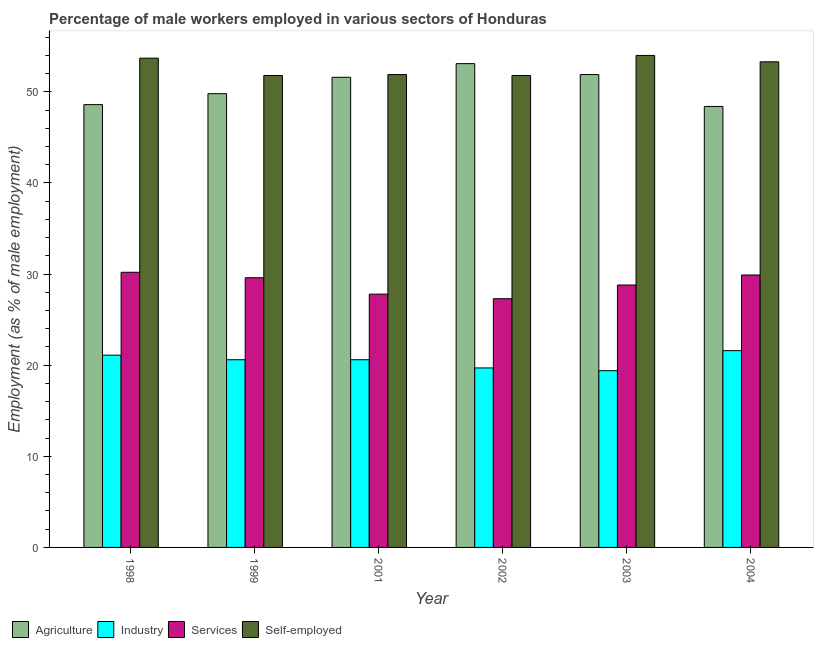How many different coloured bars are there?
Ensure brevity in your answer.  4. How many groups of bars are there?
Ensure brevity in your answer.  6. Are the number of bars per tick equal to the number of legend labels?
Ensure brevity in your answer.  Yes. Are the number of bars on each tick of the X-axis equal?
Provide a short and direct response. Yes. How many bars are there on the 1st tick from the right?
Offer a very short reply. 4. What is the label of the 3rd group of bars from the left?
Provide a short and direct response. 2001. What is the percentage of male workers in services in 1999?
Keep it short and to the point. 29.6. Across all years, what is the maximum percentage of self employed male workers?
Offer a terse response. 54. Across all years, what is the minimum percentage of self employed male workers?
Ensure brevity in your answer.  51.8. In which year was the percentage of male workers in industry minimum?
Ensure brevity in your answer.  2003. What is the total percentage of male workers in services in the graph?
Provide a short and direct response. 173.6. What is the difference between the percentage of male workers in industry in 2004 and the percentage of self employed male workers in 1998?
Offer a terse response. 0.5. What is the average percentage of male workers in industry per year?
Keep it short and to the point. 20.5. In how many years, is the percentage of self employed male workers greater than 54 %?
Give a very brief answer. 0. What is the ratio of the percentage of male workers in services in 2001 to that in 2004?
Your response must be concise. 0.93. Is the difference between the percentage of male workers in agriculture in 1998 and 2004 greater than the difference between the percentage of male workers in services in 1998 and 2004?
Ensure brevity in your answer.  No. What is the difference between the highest and the second highest percentage of male workers in services?
Give a very brief answer. 0.3. What is the difference between the highest and the lowest percentage of male workers in agriculture?
Your response must be concise. 4.7. In how many years, is the percentage of male workers in agriculture greater than the average percentage of male workers in agriculture taken over all years?
Ensure brevity in your answer.  3. Is it the case that in every year, the sum of the percentage of male workers in services and percentage of male workers in industry is greater than the sum of percentage of male workers in agriculture and percentage of self employed male workers?
Your answer should be very brief. No. What does the 4th bar from the left in 2003 represents?
Provide a succinct answer. Self-employed. What does the 1st bar from the right in 1998 represents?
Give a very brief answer. Self-employed. Is it the case that in every year, the sum of the percentage of male workers in agriculture and percentage of male workers in industry is greater than the percentage of male workers in services?
Ensure brevity in your answer.  Yes. How many bars are there?
Your response must be concise. 24. Does the graph contain grids?
Provide a short and direct response. No. Where does the legend appear in the graph?
Your response must be concise. Bottom left. How are the legend labels stacked?
Your answer should be very brief. Horizontal. What is the title of the graph?
Ensure brevity in your answer.  Percentage of male workers employed in various sectors of Honduras. What is the label or title of the X-axis?
Offer a terse response. Year. What is the label or title of the Y-axis?
Make the answer very short. Employment (as % of male employment). What is the Employment (as % of male employment) of Agriculture in 1998?
Make the answer very short. 48.6. What is the Employment (as % of male employment) in Industry in 1998?
Give a very brief answer. 21.1. What is the Employment (as % of male employment) in Services in 1998?
Your answer should be compact. 30.2. What is the Employment (as % of male employment) of Self-employed in 1998?
Your answer should be very brief. 53.7. What is the Employment (as % of male employment) of Agriculture in 1999?
Give a very brief answer. 49.8. What is the Employment (as % of male employment) in Industry in 1999?
Make the answer very short. 20.6. What is the Employment (as % of male employment) of Services in 1999?
Keep it short and to the point. 29.6. What is the Employment (as % of male employment) of Self-employed in 1999?
Provide a succinct answer. 51.8. What is the Employment (as % of male employment) of Agriculture in 2001?
Provide a succinct answer. 51.6. What is the Employment (as % of male employment) in Industry in 2001?
Offer a terse response. 20.6. What is the Employment (as % of male employment) of Services in 2001?
Your response must be concise. 27.8. What is the Employment (as % of male employment) of Self-employed in 2001?
Your response must be concise. 51.9. What is the Employment (as % of male employment) in Agriculture in 2002?
Give a very brief answer. 53.1. What is the Employment (as % of male employment) in Industry in 2002?
Offer a very short reply. 19.7. What is the Employment (as % of male employment) in Services in 2002?
Offer a very short reply. 27.3. What is the Employment (as % of male employment) of Self-employed in 2002?
Provide a short and direct response. 51.8. What is the Employment (as % of male employment) of Agriculture in 2003?
Offer a very short reply. 51.9. What is the Employment (as % of male employment) in Industry in 2003?
Ensure brevity in your answer.  19.4. What is the Employment (as % of male employment) in Services in 2003?
Your response must be concise. 28.8. What is the Employment (as % of male employment) of Agriculture in 2004?
Offer a very short reply. 48.4. What is the Employment (as % of male employment) of Industry in 2004?
Offer a very short reply. 21.6. What is the Employment (as % of male employment) of Services in 2004?
Provide a short and direct response. 29.9. What is the Employment (as % of male employment) of Self-employed in 2004?
Provide a short and direct response. 53.3. Across all years, what is the maximum Employment (as % of male employment) of Agriculture?
Keep it short and to the point. 53.1. Across all years, what is the maximum Employment (as % of male employment) in Industry?
Give a very brief answer. 21.6. Across all years, what is the maximum Employment (as % of male employment) in Services?
Offer a terse response. 30.2. Across all years, what is the minimum Employment (as % of male employment) in Agriculture?
Your answer should be compact. 48.4. Across all years, what is the minimum Employment (as % of male employment) in Industry?
Your answer should be very brief. 19.4. Across all years, what is the minimum Employment (as % of male employment) of Services?
Make the answer very short. 27.3. Across all years, what is the minimum Employment (as % of male employment) of Self-employed?
Your response must be concise. 51.8. What is the total Employment (as % of male employment) in Agriculture in the graph?
Keep it short and to the point. 303.4. What is the total Employment (as % of male employment) in Industry in the graph?
Ensure brevity in your answer.  123. What is the total Employment (as % of male employment) of Services in the graph?
Offer a terse response. 173.6. What is the total Employment (as % of male employment) in Self-employed in the graph?
Your answer should be compact. 316.5. What is the difference between the Employment (as % of male employment) of Agriculture in 1998 and that in 2001?
Keep it short and to the point. -3. What is the difference between the Employment (as % of male employment) in Industry in 1998 and that in 2002?
Ensure brevity in your answer.  1.4. What is the difference between the Employment (as % of male employment) of Industry in 1998 and that in 2003?
Your response must be concise. 1.7. What is the difference between the Employment (as % of male employment) of Services in 1998 and that in 2003?
Provide a short and direct response. 1.4. What is the difference between the Employment (as % of male employment) in Agriculture in 1998 and that in 2004?
Your answer should be very brief. 0.2. What is the difference between the Employment (as % of male employment) of Services in 1998 and that in 2004?
Your answer should be compact. 0.3. What is the difference between the Employment (as % of male employment) of Services in 1999 and that in 2002?
Ensure brevity in your answer.  2.3. What is the difference between the Employment (as % of male employment) in Self-employed in 1999 and that in 2002?
Ensure brevity in your answer.  0. What is the difference between the Employment (as % of male employment) in Agriculture in 1999 and that in 2003?
Give a very brief answer. -2.1. What is the difference between the Employment (as % of male employment) of Industry in 1999 and that in 2003?
Provide a short and direct response. 1.2. What is the difference between the Employment (as % of male employment) of Self-employed in 1999 and that in 2003?
Provide a succinct answer. -2.2. What is the difference between the Employment (as % of male employment) in Agriculture in 1999 and that in 2004?
Make the answer very short. 1.4. What is the difference between the Employment (as % of male employment) of Services in 1999 and that in 2004?
Provide a succinct answer. -0.3. What is the difference between the Employment (as % of male employment) of Self-employed in 1999 and that in 2004?
Your answer should be very brief. -1.5. What is the difference between the Employment (as % of male employment) of Industry in 2001 and that in 2002?
Provide a short and direct response. 0.9. What is the difference between the Employment (as % of male employment) in Self-employed in 2001 and that in 2002?
Provide a short and direct response. 0.1. What is the difference between the Employment (as % of male employment) of Agriculture in 2001 and that in 2003?
Your answer should be very brief. -0.3. What is the difference between the Employment (as % of male employment) of Self-employed in 2001 and that in 2003?
Keep it short and to the point. -2.1. What is the difference between the Employment (as % of male employment) in Industry in 2001 and that in 2004?
Provide a short and direct response. -1. What is the difference between the Employment (as % of male employment) of Services in 2001 and that in 2004?
Your answer should be very brief. -2.1. What is the difference between the Employment (as % of male employment) in Agriculture in 2002 and that in 2003?
Make the answer very short. 1.2. What is the difference between the Employment (as % of male employment) of Industry in 2002 and that in 2003?
Ensure brevity in your answer.  0.3. What is the difference between the Employment (as % of male employment) in Self-employed in 2002 and that in 2003?
Your answer should be very brief. -2.2. What is the difference between the Employment (as % of male employment) of Industry in 2002 and that in 2004?
Make the answer very short. -1.9. What is the difference between the Employment (as % of male employment) in Services in 2002 and that in 2004?
Your answer should be compact. -2.6. What is the difference between the Employment (as % of male employment) in Self-employed in 2002 and that in 2004?
Provide a succinct answer. -1.5. What is the difference between the Employment (as % of male employment) in Agriculture in 2003 and that in 2004?
Offer a very short reply. 3.5. What is the difference between the Employment (as % of male employment) in Industry in 2003 and that in 2004?
Provide a succinct answer. -2.2. What is the difference between the Employment (as % of male employment) of Agriculture in 1998 and the Employment (as % of male employment) of Self-employed in 1999?
Give a very brief answer. -3.2. What is the difference between the Employment (as % of male employment) of Industry in 1998 and the Employment (as % of male employment) of Self-employed in 1999?
Provide a succinct answer. -30.7. What is the difference between the Employment (as % of male employment) in Services in 1998 and the Employment (as % of male employment) in Self-employed in 1999?
Keep it short and to the point. -21.6. What is the difference between the Employment (as % of male employment) in Agriculture in 1998 and the Employment (as % of male employment) in Services in 2001?
Provide a short and direct response. 20.8. What is the difference between the Employment (as % of male employment) in Industry in 1998 and the Employment (as % of male employment) in Self-employed in 2001?
Give a very brief answer. -30.8. What is the difference between the Employment (as % of male employment) in Services in 1998 and the Employment (as % of male employment) in Self-employed in 2001?
Provide a short and direct response. -21.7. What is the difference between the Employment (as % of male employment) in Agriculture in 1998 and the Employment (as % of male employment) in Industry in 2002?
Keep it short and to the point. 28.9. What is the difference between the Employment (as % of male employment) in Agriculture in 1998 and the Employment (as % of male employment) in Services in 2002?
Give a very brief answer. 21.3. What is the difference between the Employment (as % of male employment) of Agriculture in 1998 and the Employment (as % of male employment) of Self-employed in 2002?
Provide a short and direct response. -3.2. What is the difference between the Employment (as % of male employment) of Industry in 1998 and the Employment (as % of male employment) of Services in 2002?
Keep it short and to the point. -6.2. What is the difference between the Employment (as % of male employment) in Industry in 1998 and the Employment (as % of male employment) in Self-employed in 2002?
Your answer should be compact. -30.7. What is the difference between the Employment (as % of male employment) of Services in 1998 and the Employment (as % of male employment) of Self-employed in 2002?
Offer a very short reply. -21.6. What is the difference between the Employment (as % of male employment) of Agriculture in 1998 and the Employment (as % of male employment) of Industry in 2003?
Offer a terse response. 29.2. What is the difference between the Employment (as % of male employment) in Agriculture in 1998 and the Employment (as % of male employment) in Services in 2003?
Keep it short and to the point. 19.8. What is the difference between the Employment (as % of male employment) of Agriculture in 1998 and the Employment (as % of male employment) of Self-employed in 2003?
Provide a short and direct response. -5.4. What is the difference between the Employment (as % of male employment) of Industry in 1998 and the Employment (as % of male employment) of Services in 2003?
Provide a succinct answer. -7.7. What is the difference between the Employment (as % of male employment) of Industry in 1998 and the Employment (as % of male employment) of Self-employed in 2003?
Your answer should be compact. -32.9. What is the difference between the Employment (as % of male employment) of Services in 1998 and the Employment (as % of male employment) of Self-employed in 2003?
Your response must be concise. -23.8. What is the difference between the Employment (as % of male employment) in Industry in 1998 and the Employment (as % of male employment) in Services in 2004?
Make the answer very short. -8.8. What is the difference between the Employment (as % of male employment) of Industry in 1998 and the Employment (as % of male employment) of Self-employed in 2004?
Keep it short and to the point. -32.2. What is the difference between the Employment (as % of male employment) in Services in 1998 and the Employment (as % of male employment) in Self-employed in 2004?
Your response must be concise. -23.1. What is the difference between the Employment (as % of male employment) of Agriculture in 1999 and the Employment (as % of male employment) of Industry in 2001?
Your response must be concise. 29.2. What is the difference between the Employment (as % of male employment) of Agriculture in 1999 and the Employment (as % of male employment) of Services in 2001?
Your answer should be compact. 22. What is the difference between the Employment (as % of male employment) in Industry in 1999 and the Employment (as % of male employment) in Services in 2001?
Offer a very short reply. -7.2. What is the difference between the Employment (as % of male employment) of Industry in 1999 and the Employment (as % of male employment) of Self-employed in 2001?
Provide a short and direct response. -31.3. What is the difference between the Employment (as % of male employment) in Services in 1999 and the Employment (as % of male employment) in Self-employed in 2001?
Give a very brief answer. -22.3. What is the difference between the Employment (as % of male employment) of Agriculture in 1999 and the Employment (as % of male employment) of Industry in 2002?
Ensure brevity in your answer.  30.1. What is the difference between the Employment (as % of male employment) in Agriculture in 1999 and the Employment (as % of male employment) in Services in 2002?
Ensure brevity in your answer.  22.5. What is the difference between the Employment (as % of male employment) of Agriculture in 1999 and the Employment (as % of male employment) of Self-employed in 2002?
Offer a terse response. -2. What is the difference between the Employment (as % of male employment) in Industry in 1999 and the Employment (as % of male employment) in Services in 2002?
Offer a terse response. -6.7. What is the difference between the Employment (as % of male employment) in Industry in 1999 and the Employment (as % of male employment) in Self-employed in 2002?
Your answer should be very brief. -31.2. What is the difference between the Employment (as % of male employment) of Services in 1999 and the Employment (as % of male employment) of Self-employed in 2002?
Give a very brief answer. -22.2. What is the difference between the Employment (as % of male employment) in Agriculture in 1999 and the Employment (as % of male employment) in Industry in 2003?
Your answer should be compact. 30.4. What is the difference between the Employment (as % of male employment) in Agriculture in 1999 and the Employment (as % of male employment) in Services in 2003?
Your answer should be compact. 21. What is the difference between the Employment (as % of male employment) in Industry in 1999 and the Employment (as % of male employment) in Self-employed in 2003?
Ensure brevity in your answer.  -33.4. What is the difference between the Employment (as % of male employment) in Services in 1999 and the Employment (as % of male employment) in Self-employed in 2003?
Ensure brevity in your answer.  -24.4. What is the difference between the Employment (as % of male employment) of Agriculture in 1999 and the Employment (as % of male employment) of Industry in 2004?
Provide a succinct answer. 28.2. What is the difference between the Employment (as % of male employment) in Agriculture in 1999 and the Employment (as % of male employment) in Self-employed in 2004?
Make the answer very short. -3.5. What is the difference between the Employment (as % of male employment) of Industry in 1999 and the Employment (as % of male employment) of Self-employed in 2004?
Make the answer very short. -32.7. What is the difference between the Employment (as % of male employment) of Services in 1999 and the Employment (as % of male employment) of Self-employed in 2004?
Your answer should be compact. -23.7. What is the difference between the Employment (as % of male employment) of Agriculture in 2001 and the Employment (as % of male employment) of Industry in 2002?
Offer a very short reply. 31.9. What is the difference between the Employment (as % of male employment) of Agriculture in 2001 and the Employment (as % of male employment) of Services in 2002?
Provide a short and direct response. 24.3. What is the difference between the Employment (as % of male employment) of Agriculture in 2001 and the Employment (as % of male employment) of Self-employed in 2002?
Your answer should be compact. -0.2. What is the difference between the Employment (as % of male employment) in Industry in 2001 and the Employment (as % of male employment) in Services in 2002?
Your answer should be very brief. -6.7. What is the difference between the Employment (as % of male employment) in Industry in 2001 and the Employment (as % of male employment) in Self-employed in 2002?
Keep it short and to the point. -31.2. What is the difference between the Employment (as % of male employment) of Agriculture in 2001 and the Employment (as % of male employment) of Industry in 2003?
Give a very brief answer. 32.2. What is the difference between the Employment (as % of male employment) in Agriculture in 2001 and the Employment (as % of male employment) in Services in 2003?
Your answer should be compact. 22.8. What is the difference between the Employment (as % of male employment) in Industry in 2001 and the Employment (as % of male employment) in Self-employed in 2003?
Provide a short and direct response. -33.4. What is the difference between the Employment (as % of male employment) of Services in 2001 and the Employment (as % of male employment) of Self-employed in 2003?
Provide a succinct answer. -26.2. What is the difference between the Employment (as % of male employment) in Agriculture in 2001 and the Employment (as % of male employment) in Services in 2004?
Your response must be concise. 21.7. What is the difference between the Employment (as % of male employment) of Agriculture in 2001 and the Employment (as % of male employment) of Self-employed in 2004?
Your answer should be compact. -1.7. What is the difference between the Employment (as % of male employment) of Industry in 2001 and the Employment (as % of male employment) of Services in 2004?
Your answer should be compact. -9.3. What is the difference between the Employment (as % of male employment) in Industry in 2001 and the Employment (as % of male employment) in Self-employed in 2004?
Provide a succinct answer. -32.7. What is the difference between the Employment (as % of male employment) of Services in 2001 and the Employment (as % of male employment) of Self-employed in 2004?
Ensure brevity in your answer.  -25.5. What is the difference between the Employment (as % of male employment) in Agriculture in 2002 and the Employment (as % of male employment) in Industry in 2003?
Make the answer very short. 33.7. What is the difference between the Employment (as % of male employment) in Agriculture in 2002 and the Employment (as % of male employment) in Services in 2003?
Ensure brevity in your answer.  24.3. What is the difference between the Employment (as % of male employment) of Agriculture in 2002 and the Employment (as % of male employment) of Self-employed in 2003?
Your answer should be very brief. -0.9. What is the difference between the Employment (as % of male employment) in Industry in 2002 and the Employment (as % of male employment) in Services in 2003?
Make the answer very short. -9.1. What is the difference between the Employment (as % of male employment) of Industry in 2002 and the Employment (as % of male employment) of Self-employed in 2003?
Your answer should be very brief. -34.3. What is the difference between the Employment (as % of male employment) in Services in 2002 and the Employment (as % of male employment) in Self-employed in 2003?
Make the answer very short. -26.7. What is the difference between the Employment (as % of male employment) of Agriculture in 2002 and the Employment (as % of male employment) of Industry in 2004?
Give a very brief answer. 31.5. What is the difference between the Employment (as % of male employment) of Agriculture in 2002 and the Employment (as % of male employment) of Services in 2004?
Offer a terse response. 23.2. What is the difference between the Employment (as % of male employment) of Industry in 2002 and the Employment (as % of male employment) of Self-employed in 2004?
Offer a terse response. -33.6. What is the difference between the Employment (as % of male employment) of Services in 2002 and the Employment (as % of male employment) of Self-employed in 2004?
Your answer should be compact. -26. What is the difference between the Employment (as % of male employment) in Agriculture in 2003 and the Employment (as % of male employment) in Industry in 2004?
Offer a very short reply. 30.3. What is the difference between the Employment (as % of male employment) in Industry in 2003 and the Employment (as % of male employment) in Services in 2004?
Keep it short and to the point. -10.5. What is the difference between the Employment (as % of male employment) of Industry in 2003 and the Employment (as % of male employment) of Self-employed in 2004?
Your answer should be very brief. -33.9. What is the difference between the Employment (as % of male employment) of Services in 2003 and the Employment (as % of male employment) of Self-employed in 2004?
Offer a very short reply. -24.5. What is the average Employment (as % of male employment) in Agriculture per year?
Your answer should be very brief. 50.57. What is the average Employment (as % of male employment) in Services per year?
Your answer should be very brief. 28.93. What is the average Employment (as % of male employment) in Self-employed per year?
Ensure brevity in your answer.  52.75. In the year 1998, what is the difference between the Employment (as % of male employment) in Industry and Employment (as % of male employment) in Self-employed?
Provide a short and direct response. -32.6. In the year 1998, what is the difference between the Employment (as % of male employment) in Services and Employment (as % of male employment) in Self-employed?
Your response must be concise. -23.5. In the year 1999, what is the difference between the Employment (as % of male employment) of Agriculture and Employment (as % of male employment) of Industry?
Ensure brevity in your answer.  29.2. In the year 1999, what is the difference between the Employment (as % of male employment) of Agriculture and Employment (as % of male employment) of Services?
Ensure brevity in your answer.  20.2. In the year 1999, what is the difference between the Employment (as % of male employment) in Industry and Employment (as % of male employment) in Services?
Give a very brief answer. -9. In the year 1999, what is the difference between the Employment (as % of male employment) of Industry and Employment (as % of male employment) of Self-employed?
Provide a short and direct response. -31.2. In the year 1999, what is the difference between the Employment (as % of male employment) of Services and Employment (as % of male employment) of Self-employed?
Offer a very short reply. -22.2. In the year 2001, what is the difference between the Employment (as % of male employment) of Agriculture and Employment (as % of male employment) of Services?
Give a very brief answer. 23.8. In the year 2001, what is the difference between the Employment (as % of male employment) of Agriculture and Employment (as % of male employment) of Self-employed?
Make the answer very short. -0.3. In the year 2001, what is the difference between the Employment (as % of male employment) of Industry and Employment (as % of male employment) of Self-employed?
Give a very brief answer. -31.3. In the year 2001, what is the difference between the Employment (as % of male employment) of Services and Employment (as % of male employment) of Self-employed?
Make the answer very short. -24.1. In the year 2002, what is the difference between the Employment (as % of male employment) of Agriculture and Employment (as % of male employment) of Industry?
Your answer should be very brief. 33.4. In the year 2002, what is the difference between the Employment (as % of male employment) in Agriculture and Employment (as % of male employment) in Services?
Ensure brevity in your answer.  25.8. In the year 2002, what is the difference between the Employment (as % of male employment) in Agriculture and Employment (as % of male employment) in Self-employed?
Ensure brevity in your answer.  1.3. In the year 2002, what is the difference between the Employment (as % of male employment) of Industry and Employment (as % of male employment) of Services?
Provide a succinct answer. -7.6. In the year 2002, what is the difference between the Employment (as % of male employment) in Industry and Employment (as % of male employment) in Self-employed?
Make the answer very short. -32.1. In the year 2002, what is the difference between the Employment (as % of male employment) of Services and Employment (as % of male employment) of Self-employed?
Ensure brevity in your answer.  -24.5. In the year 2003, what is the difference between the Employment (as % of male employment) in Agriculture and Employment (as % of male employment) in Industry?
Offer a terse response. 32.5. In the year 2003, what is the difference between the Employment (as % of male employment) in Agriculture and Employment (as % of male employment) in Services?
Your answer should be very brief. 23.1. In the year 2003, what is the difference between the Employment (as % of male employment) of Agriculture and Employment (as % of male employment) of Self-employed?
Ensure brevity in your answer.  -2.1. In the year 2003, what is the difference between the Employment (as % of male employment) of Industry and Employment (as % of male employment) of Self-employed?
Provide a short and direct response. -34.6. In the year 2003, what is the difference between the Employment (as % of male employment) in Services and Employment (as % of male employment) in Self-employed?
Ensure brevity in your answer.  -25.2. In the year 2004, what is the difference between the Employment (as % of male employment) in Agriculture and Employment (as % of male employment) in Industry?
Your response must be concise. 26.8. In the year 2004, what is the difference between the Employment (as % of male employment) of Industry and Employment (as % of male employment) of Services?
Provide a short and direct response. -8.3. In the year 2004, what is the difference between the Employment (as % of male employment) of Industry and Employment (as % of male employment) of Self-employed?
Make the answer very short. -31.7. In the year 2004, what is the difference between the Employment (as % of male employment) in Services and Employment (as % of male employment) in Self-employed?
Keep it short and to the point. -23.4. What is the ratio of the Employment (as % of male employment) in Agriculture in 1998 to that in 1999?
Provide a succinct answer. 0.98. What is the ratio of the Employment (as % of male employment) of Industry in 1998 to that in 1999?
Provide a succinct answer. 1.02. What is the ratio of the Employment (as % of male employment) of Services in 1998 to that in 1999?
Provide a succinct answer. 1.02. What is the ratio of the Employment (as % of male employment) of Self-employed in 1998 to that in 1999?
Ensure brevity in your answer.  1.04. What is the ratio of the Employment (as % of male employment) of Agriculture in 1998 to that in 2001?
Provide a short and direct response. 0.94. What is the ratio of the Employment (as % of male employment) in Industry in 1998 to that in 2001?
Provide a succinct answer. 1.02. What is the ratio of the Employment (as % of male employment) of Services in 1998 to that in 2001?
Offer a very short reply. 1.09. What is the ratio of the Employment (as % of male employment) in Self-employed in 1998 to that in 2001?
Your answer should be compact. 1.03. What is the ratio of the Employment (as % of male employment) in Agriculture in 1998 to that in 2002?
Keep it short and to the point. 0.92. What is the ratio of the Employment (as % of male employment) of Industry in 1998 to that in 2002?
Provide a short and direct response. 1.07. What is the ratio of the Employment (as % of male employment) of Services in 1998 to that in 2002?
Offer a terse response. 1.11. What is the ratio of the Employment (as % of male employment) in Self-employed in 1998 to that in 2002?
Make the answer very short. 1.04. What is the ratio of the Employment (as % of male employment) in Agriculture in 1998 to that in 2003?
Make the answer very short. 0.94. What is the ratio of the Employment (as % of male employment) of Industry in 1998 to that in 2003?
Offer a very short reply. 1.09. What is the ratio of the Employment (as % of male employment) in Services in 1998 to that in 2003?
Offer a very short reply. 1.05. What is the ratio of the Employment (as % of male employment) of Agriculture in 1998 to that in 2004?
Give a very brief answer. 1. What is the ratio of the Employment (as % of male employment) in Industry in 1998 to that in 2004?
Provide a short and direct response. 0.98. What is the ratio of the Employment (as % of male employment) of Self-employed in 1998 to that in 2004?
Make the answer very short. 1.01. What is the ratio of the Employment (as % of male employment) of Agriculture in 1999 to that in 2001?
Your response must be concise. 0.97. What is the ratio of the Employment (as % of male employment) in Industry in 1999 to that in 2001?
Your answer should be compact. 1. What is the ratio of the Employment (as % of male employment) of Services in 1999 to that in 2001?
Make the answer very short. 1.06. What is the ratio of the Employment (as % of male employment) of Agriculture in 1999 to that in 2002?
Ensure brevity in your answer.  0.94. What is the ratio of the Employment (as % of male employment) of Industry in 1999 to that in 2002?
Give a very brief answer. 1.05. What is the ratio of the Employment (as % of male employment) in Services in 1999 to that in 2002?
Your answer should be compact. 1.08. What is the ratio of the Employment (as % of male employment) in Agriculture in 1999 to that in 2003?
Ensure brevity in your answer.  0.96. What is the ratio of the Employment (as % of male employment) of Industry in 1999 to that in 2003?
Your response must be concise. 1.06. What is the ratio of the Employment (as % of male employment) in Services in 1999 to that in 2003?
Your answer should be compact. 1.03. What is the ratio of the Employment (as % of male employment) in Self-employed in 1999 to that in 2003?
Offer a terse response. 0.96. What is the ratio of the Employment (as % of male employment) in Agriculture in 1999 to that in 2004?
Your answer should be compact. 1.03. What is the ratio of the Employment (as % of male employment) of Industry in 1999 to that in 2004?
Keep it short and to the point. 0.95. What is the ratio of the Employment (as % of male employment) of Services in 1999 to that in 2004?
Make the answer very short. 0.99. What is the ratio of the Employment (as % of male employment) in Self-employed in 1999 to that in 2004?
Your answer should be compact. 0.97. What is the ratio of the Employment (as % of male employment) of Agriculture in 2001 to that in 2002?
Offer a terse response. 0.97. What is the ratio of the Employment (as % of male employment) in Industry in 2001 to that in 2002?
Your answer should be compact. 1.05. What is the ratio of the Employment (as % of male employment) of Services in 2001 to that in 2002?
Offer a terse response. 1.02. What is the ratio of the Employment (as % of male employment) in Industry in 2001 to that in 2003?
Your answer should be very brief. 1.06. What is the ratio of the Employment (as % of male employment) of Services in 2001 to that in 2003?
Make the answer very short. 0.97. What is the ratio of the Employment (as % of male employment) of Self-employed in 2001 to that in 2003?
Your answer should be compact. 0.96. What is the ratio of the Employment (as % of male employment) in Agriculture in 2001 to that in 2004?
Your response must be concise. 1.07. What is the ratio of the Employment (as % of male employment) of Industry in 2001 to that in 2004?
Provide a succinct answer. 0.95. What is the ratio of the Employment (as % of male employment) in Services in 2001 to that in 2004?
Offer a very short reply. 0.93. What is the ratio of the Employment (as % of male employment) of Self-employed in 2001 to that in 2004?
Your response must be concise. 0.97. What is the ratio of the Employment (as % of male employment) of Agriculture in 2002 to that in 2003?
Your response must be concise. 1.02. What is the ratio of the Employment (as % of male employment) of Industry in 2002 to that in 2003?
Offer a very short reply. 1.02. What is the ratio of the Employment (as % of male employment) in Services in 2002 to that in 2003?
Provide a succinct answer. 0.95. What is the ratio of the Employment (as % of male employment) in Self-employed in 2002 to that in 2003?
Offer a very short reply. 0.96. What is the ratio of the Employment (as % of male employment) in Agriculture in 2002 to that in 2004?
Offer a very short reply. 1.1. What is the ratio of the Employment (as % of male employment) of Industry in 2002 to that in 2004?
Provide a succinct answer. 0.91. What is the ratio of the Employment (as % of male employment) of Self-employed in 2002 to that in 2004?
Offer a terse response. 0.97. What is the ratio of the Employment (as % of male employment) of Agriculture in 2003 to that in 2004?
Offer a very short reply. 1.07. What is the ratio of the Employment (as % of male employment) in Industry in 2003 to that in 2004?
Provide a succinct answer. 0.9. What is the ratio of the Employment (as % of male employment) in Services in 2003 to that in 2004?
Your answer should be compact. 0.96. What is the ratio of the Employment (as % of male employment) in Self-employed in 2003 to that in 2004?
Make the answer very short. 1.01. What is the difference between the highest and the second highest Employment (as % of male employment) of Agriculture?
Provide a succinct answer. 1.2. What is the difference between the highest and the second highest Employment (as % of male employment) of Self-employed?
Your response must be concise. 0.3. What is the difference between the highest and the lowest Employment (as % of male employment) of Agriculture?
Your answer should be compact. 4.7. What is the difference between the highest and the lowest Employment (as % of male employment) in Industry?
Offer a very short reply. 2.2. What is the difference between the highest and the lowest Employment (as % of male employment) in Self-employed?
Keep it short and to the point. 2.2. 